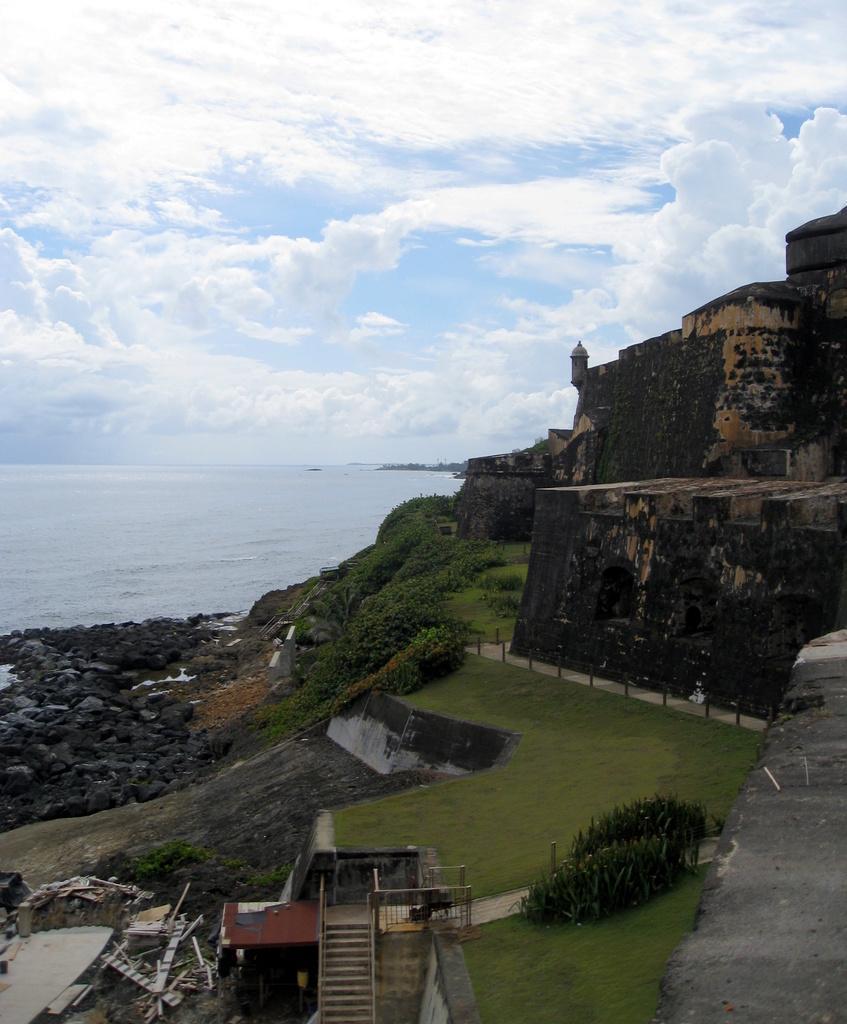Can you describe this image briefly? In this image we can see wall on the right side. Beside the wall there are a few plants and the grass. In the bottom left we can see the stairs and few objects. On the left side, we can see the rocks and the water. At the top we can see the clear sky. 